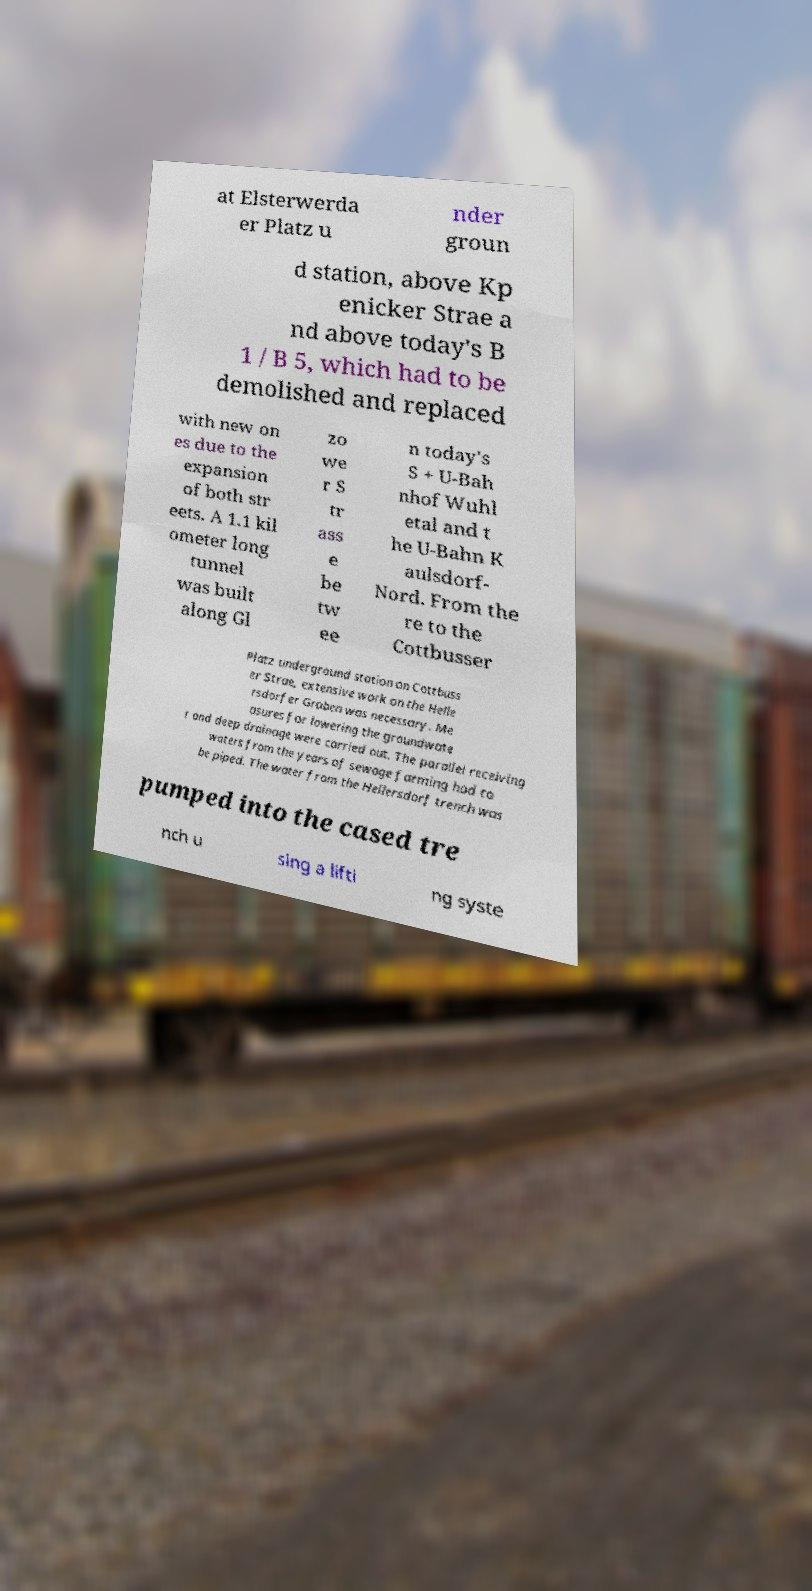For documentation purposes, I need the text within this image transcribed. Could you provide that? at Elsterwerda er Platz u nder groun d station, above Kp enicker Strae a nd above today's B 1 / B 5, which had to be demolished and replaced with new on es due to the expansion of both str eets. A 1.1 kil ometer long tunnel was built along Gl zo we r S tr ass e be tw ee n today's S + U-Bah nhof Wuhl etal and t he U-Bahn K aulsdorf- Nord. From the re to the Cottbusser Platz underground station on Cottbuss er Strae, extensive work on the Helle rsdorfer Graben was necessary. Me asures for lowering the groundwate r and deep drainage were carried out. The parallel receiving waters from the years of sewage farming had to be piped. The water from the Hellersdorf trench was pumped into the cased tre nch u sing a lifti ng syste 